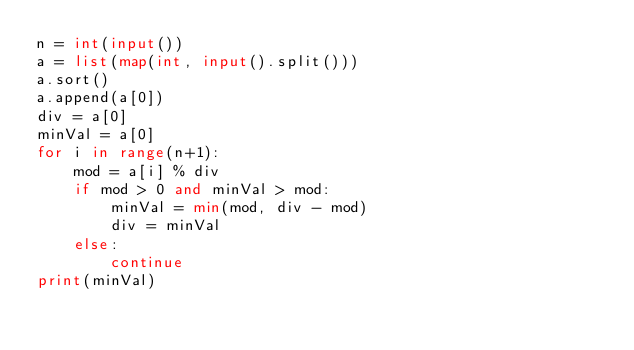Convert code to text. <code><loc_0><loc_0><loc_500><loc_500><_Python_>n = int(input())
a = list(map(int, input().split()))
a.sort()
a.append(a[0])
div = a[0]
minVal = a[0]
for i in range(n+1):
    mod = a[i] % div
    if mod > 0 and minVal > mod:
        minVal = min(mod, div - mod)
        div = minVal
    else:
        continue
print(minVal)
</code> 